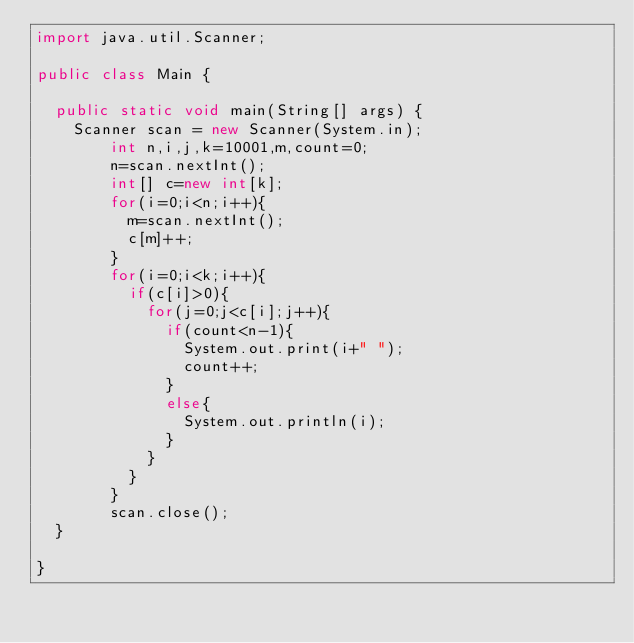Convert code to text. <code><loc_0><loc_0><loc_500><loc_500><_Java_>import java.util.Scanner;

public class Main {

	public static void main(String[] args) {
		Scanner scan = new Scanner(System.in);
        int n,i,j,k=10001,m,count=0;
        n=scan.nextInt();
        int[] c=new int[k];
        for(i=0;i<n;i++){
        	m=scan.nextInt();
        	c[m]++;
        }
        for(i=0;i<k;i++){
        	if(c[i]>0){
        		for(j=0;j<c[i];j++){
        			if(count<n-1){
        				System.out.print(i+" ");
        				count++;
        			}
        			else{
        				System.out.println(i);
        			}
        		}
        	}
        }
        scan.close();
	}

}

</code> 